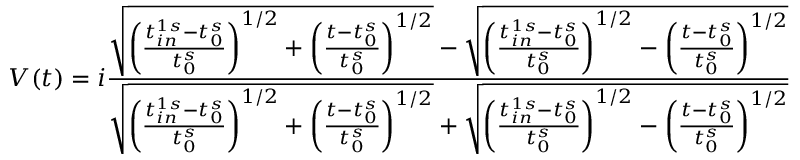<formula> <loc_0><loc_0><loc_500><loc_500>V ( t ) = i \frac { \sqrt { \left ( \frac { t _ { i n } ^ { 1 s } - t _ { 0 } ^ { s } } { t _ { 0 } ^ { s } } \right ) ^ { 1 / 2 } + \left ( \frac { t - t _ { 0 } ^ { s } } { t _ { 0 } ^ { s } } \right ) ^ { 1 / 2 } } - \sqrt { \left ( \frac { t _ { i n } ^ { 1 s } - t _ { 0 } ^ { s } } { t _ { 0 } ^ { s } } \right ) ^ { 1 / 2 } - \left ( \frac { t - t _ { 0 } ^ { s } } { t _ { 0 } ^ { s } } \right ) ^ { 1 / 2 } } } { \sqrt { \left ( \frac { t _ { i n } ^ { 1 s } - t _ { 0 } ^ { s } } { t _ { 0 } ^ { s } } \right ) ^ { 1 / 2 } + \left ( \frac { t - t _ { 0 } ^ { s } } { t _ { 0 } ^ { s } } \right ) ^ { 1 / 2 } } + \sqrt { \left ( \frac { t _ { i n } ^ { 1 s } - t _ { 0 } ^ { s } } { t _ { 0 } ^ { s } } \right ) ^ { 1 / 2 } - \left ( \frac { t - t _ { 0 } ^ { s } } { t _ { 0 } ^ { s } } \right ) ^ { 1 / 2 } } }</formula> 